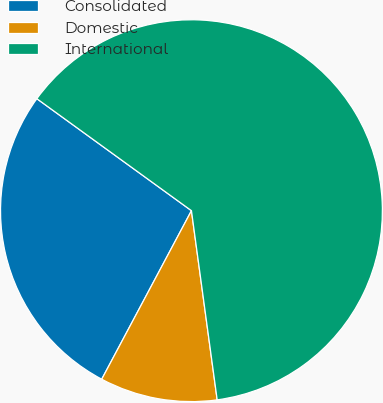Convert chart. <chart><loc_0><loc_0><loc_500><loc_500><pie_chart><fcel>Consolidated<fcel>Domestic<fcel>International<nl><fcel>27.19%<fcel>9.94%<fcel>62.87%<nl></chart> 